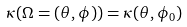<formula> <loc_0><loc_0><loc_500><loc_500>\kappa ( \Omega = ( \theta , \phi ) ) = \kappa ( \theta , \phi _ { 0 } )</formula> 